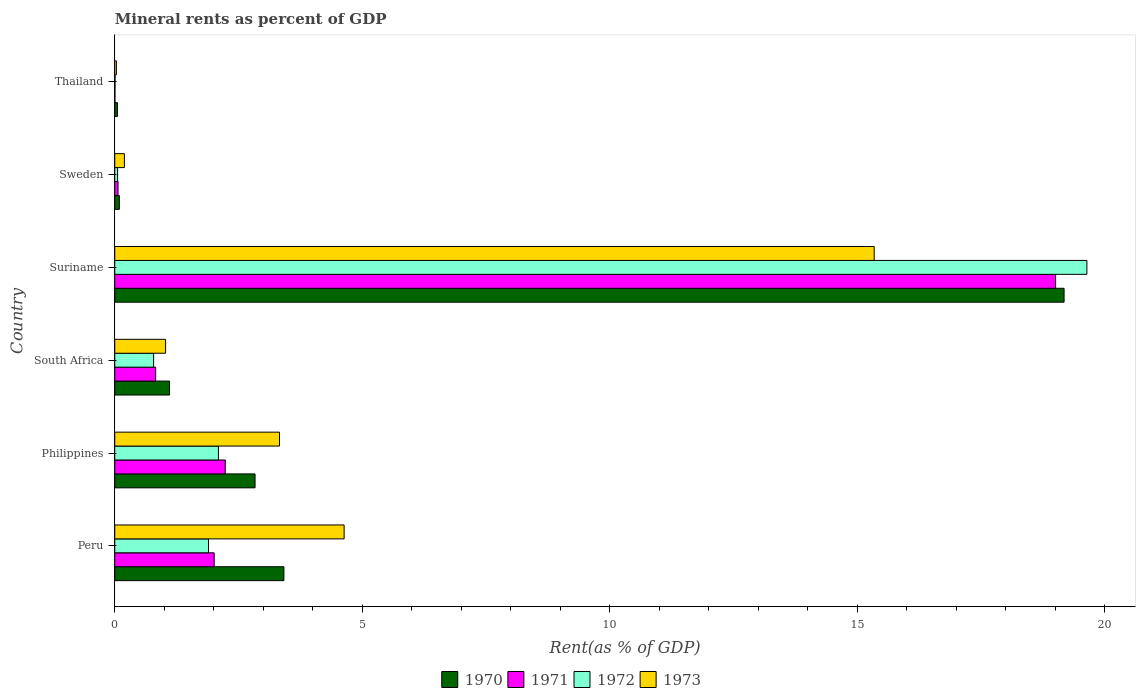How many groups of bars are there?
Your response must be concise. 6. Are the number of bars per tick equal to the number of legend labels?
Your answer should be compact. Yes. Are the number of bars on each tick of the Y-axis equal?
Your answer should be compact. Yes. How many bars are there on the 4th tick from the top?
Provide a short and direct response. 4. How many bars are there on the 1st tick from the bottom?
Provide a succinct answer. 4. What is the label of the 1st group of bars from the top?
Provide a succinct answer. Thailand. In how many cases, is the number of bars for a given country not equal to the number of legend labels?
Keep it short and to the point. 0. What is the mineral rent in 1973 in Thailand?
Keep it short and to the point. 0.03. Across all countries, what is the maximum mineral rent in 1972?
Offer a terse response. 19.63. Across all countries, what is the minimum mineral rent in 1971?
Your answer should be compact. 0. In which country was the mineral rent in 1972 maximum?
Your answer should be compact. Suriname. In which country was the mineral rent in 1971 minimum?
Offer a very short reply. Thailand. What is the total mineral rent in 1973 in the graph?
Offer a terse response. 24.55. What is the difference between the mineral rent in 1971 in Peru and that in Thailand?
Provide a succinct answer. 2. What is the difference between the mineral rent in 1972 in Suriname and the mineral rent in 1973 in Thailand?
Your answer should be compact. 19.6. What is the average mineral rent in 1971 per country?
Give a very brief answer. 4.02. What is the difference between the mineral rent in 1973 and mineral rent in 1972 in Philippines?
Give a very brief answer. 1.23. In how many countries, is the mineral rent in 1972 greater than 5 %?
Your response must be concise. 1. What is the ratio of the mineral rent in 1973 in Philippines to that in Thailand?
Provide a short and direct response. 100.47. Is the mineral rent in 1972 in Philippines less than that in Suriname?
Offer a very short reply. Yes. Is the difference between the mineral rent in 1973 in Philippines and Suriname greater than the difference between the mineral rent in 1972 in Philippines and Suriname?
Your response must be concise. Yes. What is the difference between the highest and the second highest mineral rent in 1972?
Provide a succinct answer. 17.54. What is the difference between the highest and the lowest mineral rent in 1970?
Your answer should be very brief. 19.12. Is it the case that in every country, the sum of the mineral rent in 1971 and mineral rent in 1972 is greater than the sum of mineral rent in 1973 and mineral rent in 1970?
Give a very brief answer. No. What does the 1st bar from the top in Sweden represents?
Provide a succinct answer. 1973. What does the 4th bar from the bottom in Suriname represents?
Offer a very short reply. 1973. How many bars are there?
Keep it short and to the point. 24. How many countries are there in the graph?
Ensure brevity in your answer.  6. What is the difference between two consecutive major ticks on the X-axis?
Offer a terse response. 5. Does the graph contain any zero values?
Give a very brief answer. No. Does the graph contain grids?
Your answer should be very brief. No. How many legend labels are there?
Your response must be concise. 4. How are the legend labels stacked?
Give a very brief answer. Horizontal. What is the title of the graph?
Give a very brief answer. Mineral rents as percent of GDP. What is the label or title of the X-axis?
Give a very brief answer. Rent(as % of GDP). What is the Rent(as % of GDP) of 1970 in Peru?
Provide a short and direct response. 3.42. What is the Rent(as % of GDP) in 1971 in Peru?
Offer a terse response. 2.01. What is the Rent(as % of GDP) of 1972 in Peru?
Make the answer very short. 1.89. What is the Rent(as % of GDP) in 1973 in Peru?
Give a very brief answer. 4.63. What is the Rent(as % of GDP) of 1970 in Philippines?
Offer a terse response. 2.83. What is the Rent(as % of GDP) of 1971 in Philippines?
Give a very brief answer. 2.23. What is the Rent(as % of GDP) in 1972 in Philippines?
Provide a succinct answer. 2.09. What is the Rent(as % of GDP) in 1973 in Philippines?
Keep it short and to the point. 3.33. What is the Rent(as % of GDP) of 1970 in South Africa?
Make the answer very short. 1.11. What is the Rent(as % of GDP) in 1971 in South Africa?
Offer a terse response. 0.83. What is the Rent(as % of GDP) in 1972 in South Africa?
Ensure brevity in your answer.  0.79. What is the Rent(as % of GDP) in 1973 in South Africa?
Provide a short and direct response. 1.03. What is the Rent(as % of GDP) of 1970 in Suriname?
Give a very brief answer. 19.17. What is the Rent(as % of GDP) of 1971 in Suriname?
Ensure brevity in your answer.  19. What is the Rent(as % of GDP) in 1972 in Suriname?
Give a very brief answer. 19.63. What is the Rent(as % of GDP) in 1973 in Suriname?
Offer a terse response. 15.34. What is the Rent(as % of GDP) in 1970 in Sweden?
Keep it short and to the point. 0.09. What is the Rent(as % of GDP) in 1971 in Sweden?
Keep it short and to the point. 0.07. What is the Rent(as % of GDP) of 1972 in Sweden?
Your answer should be compact. 0.06. What is the Rent(as % of GDP) of 1973 in Sweden?
Provide a short and direct response. 0.2. What is the Rent(as % of GDP) in 1970 in Thailand?
Keep it short and to the point. 0.05. What is the Rent(as % of GDP) in 1971 in Thailand?
Provide a succinct answer. 0. What is the Rent(as % of GDP) of 1972 in Thailand?
Make the answer very short. 0.01. What is the Rent(as % of GDP) of 1973 in Thailand?
Offer a terse response. 0.03. Across all countries, what is the maximum Rent(as % of GDP) of 1970?
Provide a short and direct response. 19.17. Across all countries, what is the maximum Rent(as % of GDP) in 1971?
Offer a very short reply. 19. Across all countries, what is the maximum Rent(as % of GDP) in 1972?
Your answer should be compact. 19.63. Across all countries, what is the maximum Rent(as % of GDP) in 1973?
Ensure brevity in your answer.  15.34. Across all countries, what is the minimum Rent(as % of GDP) of 1970?
Ensure brevity in your answer.  0.05. Across all countries, what is the minimum Rent(as % of GDP) of 1971?
Ensure brevity in your answer.  0. Across all countries, what is the minimum Rent(as % of GDP) of 1972?
Offer a very short reply. 0.01. Across all countries, what is the minimum Rent(as % of GDP) in 1973?
Offer a very short reply. 0.03. What is the total Rent(as % of GDP) of 1970 in the graph?
Make the answer very short. 26.68. What is the total Rent(as % of GDP) of 1971 in the graph?
Provide a short and direct response. 24.14. What is the total Rent(as % of GDP) of 1972 in the graph?
Your answer should be very brief. 24.47. What is the total Rent(as % of GDP) of 1973 in the graph?
Your answer should be very brief. 24.55. What is the difference between the Rent(as % of GDP) in 1970 in Peru and that in Philippines?
Offer a very short reply. 0.58. What is the difference between the Rent(as % of GDP) of 1971 in Peru and that in Philippines?
Offer a terse response. -0.22. What is the difference between the Rent(as % of GDP) in 1972 in Peru and that in Philippines?
Offer a terse response. -0.2. What is the difference between the Rent(as % of GDP) in 1973 in Peru and that in Philippines?
Provide a succinct answer. 1.31. What is the difference between the Rent(as % of GDP) in 1970 in Peru and that in South Africa?
Provide a succinct answer. 2.31. What is the difference between the Rent(as % of GDP) of 1971 in Peru and that in South Africa?
Give a very brief answer. 1.18. What is the difference between the Rent(as % of GDP) of 1972 in Peru and that in South Africa?
Provide a succinct answer. 1.11. What is the difference between the Rent(as % of GDP) of 1973 in Peru and that in South Africa?
Offer a very short reply. 3.61. What is the difference between the Rent(as % of GDP) in 1970 in Peru and that in Suriname?
Make the answer very short. -15.76. What is the difference between the Rent(as % of GDP) of 1971 in Peru and that in Suriname?
Provide a short and direct response. -16.99. What is the difference between the Rent(as % of GDP) of 1972 in Peru and that in Suriname?
Ensure brevity in your answer.  -17.74. What is the difference between the Rent(as % of GDP) in 1973 in Peru and that in Suriname?
Your answer should be very brief. -10.71. What is the difference between the Rent(as % of GDP) of 1970 in Peru and that in Sweden?
Provide a short and direct response. 3.32. What is the difference between the Rent(as % of GDP) of 1971 in Peru and that in Sweden?
Keep it short and to the point. 1.94. What is the difference between the Rent(as % of GDP) of 1972 in Peru and that in Sweden?
Ensure brevity in your answer.  1.84. What is the difference between the Rent(as % of GDP) in 1973 in Peru and that in Sweden?
Provide a short and direct response. 4.44. What is the difference between the Rent(as % of GDP) of 1970 in Peru and that in Thailand?
Your answer should be compact. 3.36. What is the difference between the Rent(as % of GDP) in 1971 in Peru and that in Thailand?
Provide a short and direct response. 2. What is the difference between the Rent(as % of GDP) of 1972 in Peru and that in Thailand?
Provide a short and direct response. 1.89. What is the difference between the Rent(as % of GDP) in 1973 in Peru and that in Thailand?
Provide a short and direct response. 4.6. What is the difference between the Rent(as % of GDP) of 1970 in Philippines and that in South Africa?
Keep it short and to the point. 1.73. What is the difference between the Rent(as % of GDP) in 1971 in Philippines and that in South Africa?
Your answer should be compact. 1.41. What is the difference between the Rent(as % of GDP) in 1972 in Philippines and that in South Africa?
Provide a succinct answer. 1.31. What is the difference between the Rent(as % of GDP) of 1973 in Philippines and that in South Africa?
Ensure brevity in your answer.  2.3. What is the difference between the Rent(as % of GDP) in 1970 in Philippines and that in Suriname?
Offer a terse response. -16.34. What is the difference between the Rent(as % of GDP) in 1971 in Philippines and that in Suriname?
Your response must be concise. -16.77. What is the difference between the Rent(as % of GDP) in 1972 in Philippines and that in Suriname?
Make the answer very short. -17.54. What is the difference between the Rent(as % of GDP) of 1973 in Philippines and that in Suriname?
Your answer should be compact. -12.01. What is the difference between the Rent(as % of GDP) of 1970 in Philippines and that in Sweden?
Keep it short and to the point. 2.74. What is the difference between the Rent(as % of GDP) in 1971 in Philippines and that in Sweden?
Provide a succinct answer. 2.17. What is the difference between the Rent(as % of GDP) in 1972 in Philippines and that in Sweden?
Your response must be concise. 2.04. What is the difference between the Rent(as % of GDP) in 1973 in Philippines and that in Sweden?
Provide a short and direct response. 3.13. What is the difference between the Rent(as % of GDP) of 1970 in Philippines and that in Thailand?
Provide a succinct answer. 2.78. What is the difference between the Rent(as % of GDP) in 1971 in Philippines and that in Thailand?
Your response must be concise. 2.23. What is the difference between the Rent(as % of GDP) of 1972 in Philippines and that in Thailand?
Offer a very short reply. 2.09. What is the difference between the Rent(as % of GDP) of 1973 in Philippines and that in Thailand?
Provide a succinct answer. 3.29. What is the difference between the Rent(as % of GDP) in 1970 in South Africa and that in Suriname?
Ensure brevity in your answer.  -18.07. What is the difference between the Rent(as % of GDP) of 1971 in South Africa and that in Suriname?
Your answer should be compact. -18.18. What is the difference between the Rent(as % of GDP) in 1972 in South Africa and that in Suriname?
Offer a terse response. -18.85. What is the difference between the Rent(as % of GDP) of 1973 in South Africa and that in Suriname?
Provide a succinct answer. -14.31. What is the difference between the Rent(as % of GDP) in 1970 in South Africa and that in Sweden?
Offer a very short reply. 1.01. What is the difference between the Rent(as % of GDP) in 1971 in South Africa and that in Sweden?
Offer a very short reply. 0.76. What is the difference between the Rent(as % of GDP) in 1972 in South Africa and that in Sweden?
Your answer should be very brief. 0.73. What is the difference between the Rent(as % of GDP) in 1973 in South Africa and that in Sweden?
Provide a short and direct response. 0.83. What is the difference between the Rent(as % of GDP) of 1970 in South Africa and that in Thailand?
Provide a short and direct response. 1.05. What is the difference between the Rent(as % of GDP) of 1971 in South Africa and that in Thailand?
Keep it short and to the point. 0.82. What is the difference between the Rent(as % of GDP) in 1972 in South Africa and that in Thailand?
Offer a terse response. 0.78. What is the difference between the Rent(as % of GDP) of 1970 in Suriname and that in Sweden?
Your answer should be compact. 19.08. What is the difference between the Rent(as % of GDP) of 1971 in Suriname and that in Sweden?
Your answer should be compact. 18.94. What is the difference between the Rent(as % of GDP) in 1972 in Suriname and that in Sweden?
Keep it short and to the point. 19.58. What is the difference between the Rent(as % of GDP) of 1973 in Suriname and that in Sweden?
Provide a short and direct response. 15.14. What is the difference between the Rent(as % of GDP) in 1970 in Suriname and that in Thailand?
Provide a succinct answer. 19.12. What is the difference between the Rent(as % of GDP) in 1971 in Suriname and that in Thailand?
Offer a very short reply. 19. What is the difference between the Rent(as % of GDP) in 1972 in Suriname and that in Thailand?
Your answer should be compact. 19.63. What is the difference between the Rent(as % of GDP) of 1973 in Suriname and that in Thailand?
Give a very brief answer. 15.31. What is the difference between the Rent(as % of GDP) in 1970 in Sweden and that in Thailand?
Offer a very short reply. 0.04. What is the difference between the Rent(as % of GDP) of 1971 in Sweden and that in Thailand?
Ensure brevity in your answer.  0.06. What is the difference between the Rent(as % of GDP) of 1972 in Sweden and that in Thailand?
Your response must be concise. 0.05. What is the difference between the Rent(as % of GDP) in 1973 in Sweden and that in Thailand?
Give a very brief answer. 0.16. What is the difference between the Rent(as % of GDP) of 1970 in Peru and the Rent(as % of GDP) of 1971 in Philippines?
Your answer should be very brief. 1.18. What is the difference between the Rent(as % of GDP) in 1970 in Peru and the Rent(as % of GDP) in 1972 in Philippines?
Make the answer very short. 1.32. What is the difference between the Rent(as % of GDP) in 1970 in Peru and the Rent(as % of GDP) in 1973 in Philippines?
Your answer should be compact. 0.09. What is the difference between the Rent(as % of GDP) of 1971 in Peru and the Rent(as % of GDP) of 1972 in Philippines?
Provide a succinct answer. -0.09. What is the difference between the Rent(as % of GDP) in 1971 in Peru and the Rent(as % of GDP) in 1973 in Philippines?
Give a very brief answer. -1.32. What is the difference between the Rent(as % of GDP) of 1972 in Peru and the Rent(as % of GDP) of 1973 in Philippines?
Your answer should be compact. -1.43. What is the difference between the Rent(as % of GDP) in 1970 in Peru and the Rent(as % of GDP) in 1971 in South Africa?
Your response must be concise. 2.59. What is the difference between the Rent(as % of GDP) of 1970 in Peru and the Rent(as % of GDP) of 1972 in South Africa?
Provide a short and direct response. 2.63. What is the difference between the Rent(as % of GDP) of 1970 in Peru and the Rent(as % of GDP) of 1973 in South Africa?
Keep it short and to the point. 2.39. What is the difference between the Rent(as % of GDP) of 1971 in Peru and the Rent(as % of GDP) of 1972 in South Africa?
Make the answer very short. 1.22. What is the difference between the Rent(as % of GDP) in 1971 in Peru and the Rent(as % of GDP) in 1973 in South Africa?
Keep it short and to the point. 0.98. What is the difference between the Rent(as % of GDP) of 1972 in Peru and the Rent(as % of GDP) of 1973 in South Africa?
Offer a very short reply. 0.87. What is the difference between the Rent(as % of GDP) in 1970 in Peru and the Rent(as % of GDP) in 1971 in Suriname?
Your answer should be very brief. -15.59. What is the difference between the Rent(as % of GDP) in 1970 in Peru and the Rent(as % of GDP) in 1972 in Suriname?
Your answer should be very brief. -16.22. What is the difference between the Rent(as % of GDP) of 1970 in Peru and the Rent(as % of GDP) of 1973 in Suriname?
Provide a short and direct response. -11.92. What is the difference between the Rent(as % of GDP) in 1971 in Peru and the Rent(as % of GDP) in 1972 in Suriname?
Give a very brief answer. -17.63. What is the difference between the Rent(as % of GDP) in 1971 in Peru and the Rent(as % of GDP) in 1973 in Suriname?
Your answer should be compact. -13.33. What is the difference between the Rent(as % of GDP) in 1972 in Peru and the Rent(as % of GDP) in 1973 in Suriname?
Your answer should be very brief. -13.44. What is the difference between the Rent(as % of GDP) of 1970 in Peru and the Rent(as % of GDP) of 1971 in Sweden?
Give a very brief answer. 3.35. What is the difference between the Rent(as % of GDP) of 1970 in Peru and the Rent(as % of GDP) of 1972 in Sweden?
Offer a very short reply. 3.36. What is the difference between the Rent(as % of GDP) in 1970 in Peru and the Rent(as % of GDP) in 1973 in Sweden?
Ensure brevity in your answer.  3.22. What is the difference between the Rent(as % of GDP) of 1971 in Peru and the Rent(as % of GDP) of 1972 in Sweden?
Offer a terse response. 1.95. What is the difference between the Rent(as % of GDP) in 1971 in Peru and the Rent(as % of GDP) in 1973 in Sweden?
Offer a very short reply. 1.81. What is the difference between the Rent(as % of GDP) in 1972 in Peru and the Rent(as % of GDP) in 1973 in Sweden?
Give a very brief answer. 1.7. What is the difference between the Rent(as % of GDP) of 1970 in Peru and the Rent(as % of GDP) of 1971 in Thailand?
Provide a succinct answer. 3.41. What is the difference between the Rent(as % of GDP) in 1970 in Peru and the Rent(as % of GDP) in 1972 in Thailand?
Ensure brevity in your answer.  3.41. What is the difference between the Rent(as % of GDP) in 1970 in Peru and the Rent(as % of GDP) in 1973 in Thailand?
Make the answer very short. 3.38. What is the difference between the Rent(as % of GDP) in 1971 in Peru and the Rent(as % of GDP) in 1972 in Thailand?
Your answer should be very brief. 2. What is the difference between the Rent(as % of GDP) in 1971 in Peru and the Rent(as % of GDP) in 1973 in Thailand?
Offer a terse response. 1.97. What is the difference between the Rent(as % of GDP) in 1972 in Peru and the Rent(as % of GDP) in 1973 in Thailand?
Offer a very short reply. 1.86. What is the difference between the Rent(as % of GDP) of 1970 in Philippines and the Rent(as % of GDP) of 1971 in South Africa?
Your answer should be very brief. 2.01. What is the difference between the Rent(as % of GDP) in 1970 in Philippines and the Rent(as % of GDP) in 1972 in South Africa?
Ensure brevity in your answer.  2.05. What is the difference between the Rent(as % of GDP) in 1970 in Philippines and the Rent(as % of GDP) in 1973 in South Africa?
Provide a short and direct response. 1.81. What is the difference between the Rent(as % of GDP) in 1971 in Philippines and the Rent(as % of GDP) in 1972 in South Africa?
Ensure brevity in your answer.  1.45. What is the difference between the Rent(as % of GDP) of 1971 in Philippines and the Rent(as % of GDP) of 1973 in South Africa?
Your answer should be compact. 1.2. What is the difference between the Rent(as % of GDP) in 1972 in Philippines and the Rent(as % of GDP) in 1973 in South Africa?
Offer a very short reply. 1.07. What is the difference between the Rent(as % of GDP) of 1970 in Philippines and the Rent(as % of GDP) of 1971 in Suriname?
Provide a succinct answer. -16.17. What is the difference between the Rent(as % of GDP) of 1970 in Philippines and the Rent(as % of GDP) of 1972 in Suriname?
Keep it short and to the point. -16.8. What is the difference between the Rent(as % of GDP) of 1970 in Philippines and the Rent(as % of GDP) of 1973 in Suriname?
Your answer should be very brief. -12.51. What is the difference between the Rent(as % of GDP) in 1971 in Philippines and the Rent(as % of GDP) in 1972 in Suriname?
Provide a short and direct response. -17.4. What is the difference between the Rent(as % of GDP) of 1971 in Philippines and the Rent(as % of GDP) of 1973 in Suriname?
Your response must be concise. -13.11. What is the difference between the Rent(as % of GDP) of 1972 in Philippines and the Rent(as % of GDP) of 1973 in Suriname?
Provide a short and direct response. -13.24. What is the difference between the Rent(as % of GDP) in 1970 in Philippines and the Rent(as % of GDP) in 1971 in Sweden?
Provide a succinct answer. 2.77. What is the difference between the Rent(as % of GDP) of 1970 in Philippines and the Rent(as % of GDP) of 1972 in Sweden?
Make the answer very short. 2.78. What is the difference between the Rent(as % of GDP) of 1970 in Philippines and the Rent(as % of GDP) of 1973 in Sweden?
Provide a succinct answer. 2.64. What is the difference between the Rent(as % of GDP) in 1971 in Philippines and the Rent(as % of GDP) in 1972 in Sweden?
Ensure brevity in your answer.  2.17. What is the difference between the Rent(as % of GDP) in 1971 in Philippines and the Rent(as % of GDP) in 1973 in Sweden?
Offer a terse response. 2.04. What is the difference between the Rent(as % of GDP) in 1972 in Philippines and the Rent(as % of GDP) in 1973 in Sweden?
Keep it short and to the point. 1.9. What is the difference between the Rent(as % of GDP) in 1970 in Philippines and the Rent(as % of GDP) in 1971 in Thailand?
Offer a very short reply. 2.83. What is the difference between the Rent(as % of GDP) in 1970 in Philippines and the Rent(as % of GDP) in 1972 in Thailand?
Offer a terse response. 2.83. What is the difference between the Rent(as % of GDP) in 1970 in Philippines and the Rent(as % of GDP) in 1973 in Thailand?
Your answer should be very brief. 2.8. What is the difference between the Rent(as % of GDP) of 1971 in Philippines and the Rent(as % of GDP) of 1972 in Thailand?
Give a very brief answer. 2.23. What is the difference between the Rent(as % of GDP) of 1971 in Philippines and the Rent(as % of GDP) of 1973 in Thailand?
Give a very brief answer. 2.2. What is the difference between the Rent(as % of GDP) in 1972 in Philippines and the Rent(as % of GDP) in 1973 in Thailand?
Your answer should be very brief. 2.06. What is the difference between the Rent(as % of GDP) in 1970 in South Africa and the Rent(as % of GDP) in 1971 in Suriname?
Give a very brief answer. -17.9. What is the difference between the Rent(as % of GDP) in 1970 in South Africa and the Rent(as % of GDP) in 1972 in Suriname?
Make the answer very short. -18.53. What is the difference between the Rent(as % of GDP) in 1970 in South Africa and the Rent(as % of GDP) in 1973 in Suriname?
Ensure brevity in your answer.  -14.23. What is the difference between the Rent(as % of GDP) of 1971 in South Africa and the Rent(as % of GDP) of 1972 in Suriname?
Your answer should be compact. -18.81. What is the difference between the Rent(as % of GDP) in 1971 in South Africa and the Rent(as % of GDP) in 1973 in Suriname?
Your answer should be compact. -14.51. What is the difference between the Rent(as % of GDP) in 1972 in South Africa and the Rent(as % of GDP) in 1973 in Suriname?
Give a very brief answer. -14.55. What is the difference between the Rent(as % of GDP) in 1970 in South Africa and the Rent(as % of GDP) in 1971 in Sweden?
Provide a succinct answer. 1.04. What is the difference between the Rent(as % of GDP) of 1970 in South Africa and the Rent(as % of GDP) of 1972 in Sweden?
Your answer should be very brief. 1.05. What is the difference between the Rent(as % of GDP) of 1970 in South Africa and the Rent(as % of GDP) of 1973 in Sweden?
Provide a short and direct response. 0.91. What is the difference between the Rent(as % of GDP) in 1971 in South Africa and the Rent(as % of GDP) in 1972 in Sweden?
Your response must be concise. 0.77. What is the difference between the Rent(as % of GDP) in 1971 in South Africa and the Rent(as % of GDP) in 1973 in Sweden?
Your response must be concise. 0.63. What is the difference between the Rent(as % of GDP) in 1972 in South Africa and the Rent(as % of GDP) in 1973 in Sweden?
Offer a terse response. 0.59. What is the difference between the Rent(as % of GDP) of 1970 in South Africa and the Rent(as % of GDP) of 1971 in Thailand?
Your answer should be very brief. 1.1. What is the difference between the Rent(as % of GDP) in 1970 in South Africa and the Rent(as % of GDP) in 1972 in Thailand?
Make the answer very short. 1.1. What is the difference between the Rent(as % of GDP) in 1970 in South Africa and the Rent(as % of GDP) in 1973 in Thailand?
Offer a terse response. 1.07. What is the difference between the Rent(as % of GDP) in 1971 in South Africa and the Rent(as % of GDP) in 1972 in Thailand?
Offer a very short reply. 0.82. What is the difference between the Rent(as % of GDP) in 1971 in South Africa and the Rent(as % of GDP) in 1973 in Thailand?
Ensure brevity in your answer.  0.79. What is the difference between the Rent(as % of GDP) in 1972 in South Africa and the Rent(as % of GDP) in 1973 in Thailand?
Your response must be concise. 0.75. What is the difference between the Rent(as % of GDP) in 1970 in Suriname and the Rent(as % of GDP) in 1971 in Sweden?
Your answer should be very brief. 19.11. What is the difference between the Rent(as % of GDP) in 1970 in Suriname and the Rent(as % of GDP) in 1972 in Sweden?
Provide a succinct answer. 19.12. What is the difference between the Rent(as % of GDP) in 1970 in Suriname and the Rent(as % of GDP) in 1973 in Sweden?
Make the answer very short. 18.98. What is the difference between the Rent(as % of GDP) of 1971 in Suriname and the Rent(as % of GDP) of 1972 in Sweden?
Ensure brevity in your answer.  18.95. What is the difference between the Rent(as % of GDP) in 1971 in Suriname and the Rent(as % of GDP) in 1973 in Sweden?
Make the answer very short. 18.81. What is the difference between the Rent(as % of GDP) of 1972 in Suriname and the Rent(as % of GDP) of 1973 in Sweden?
Your answer should be very brief. 19.44. What is the difference between the Rent(as % of GDP) in 1970 in Suriname and the Rent(as % of GDP) in 1971 in Thailand?
Offer a terse response. 19.17. What is the difference between the Rent(as % of GDP) in 1970 in Suriname and the Rent(as % of GDP) in 1972 in Thailand?
Your response must be concise. 19.17. What is the difference between the Rent(as % of GDP) in 1970 in Suriname and the Rent(as % of GDP) in 1973 in Thailand?
Make the answer very short. 19.14. What is the difference between the Rent(as % of GDP) of 1971 in Suriname and the Rent(as % of GDP) of 1972 in Thailand?
Make the answer very short. 19. What is the difference between the Rent(as % of GDP) of 1971 in Suriname and the Rent(as % of GDP) of 1973 in Thailand?
Offer a very short reply. 18.97. What is the difference between the Rent(as % of GDP) in 1972 in Suriname and the Rent(as % of GDP) in 1973 in Thailand?
Your response must be concise. 19.6. What is the difference between the Rent(as % of GDP) in 1970 in Sweden and the Rent(as % of GDP) in 1971 in Thailand?
Your response must be concise. 0.09. What is the difference between the Rent(as % of GDP) of 1970 in Sweden and the Rent(as % of GDP) of 1972 in Thailand?
Offer a terse response. 0.09. What is the difference between the Rent(as % of GDP) in 1970 in Sweden and the Rent(as % of GDP) in 1973 in Thailand?
Offer a terse response. 0.06. What is the difference between the Rent(as % of GDP) of 1971 in Sweden and the Rent(as % of GDP) of 1972 in Thailand?
Offer a very short reply. 0.06. What is the difference between the Rent(as % of GDP) in 1971 in Sweden and the Rent(as % of GDP) in 1973 in Thailand?
Your response must be concise. 0.03. What is the difference between the Rent(as % of GDP) of 1972 in Sweden and the Rent(as % of GDP) of 1973 in Thailand?
Your response must be concise. 0.02. What is the average Rent(as % of GDP) of 1970 per country?
Ensure brevity in your answer.  4.45. What is the average Rent(as % of GDP) of 1971 per country?
Provide a succinct answer. 4.02. What is the average Rent(as % of GDP) of 1972 per country?
Offer a very short reply. 4.08. What is the average Rent(as % of GDP) in 1973 per country?
Provide a short and direct response. 4.09. What is the difference between the Rent(as % of GDP) in 1970 and Rent(as % of GDP) in 1971 in Peru?
Ensure brevity in your answer.  1.41. What is the difference between the Rent(as % of GDP) of 1970 and Rent(as % of GDP) of 1972 in Peru?
Ensure brevity in your answer.  1.52. What is the difference between the Rent(as % of GDP) in 1970 and Rent(as % of GDP) in 1973 in Peru?
Your answer should be very brief. -1.22. What is the difference between the Rent(as % of GDP) in 1971 and Rent(as % of GDP) in 1972 in Peru?
Your answer should be very brief. 0.11. What is the difference between the Rent(as % of GDP) in 1971 and Rent(as % of GDP) in 1973 in Peru?
Offer a very short reply. -2.62. What is the difference between the Rent(as % of GDP) of 1972 and Rent(as % of GDP) of 1973 in Peru?
Provide a succinct answer. -2.74. What is the difference between the Rent(as % of GDP) in 1970 and Rent(as % of GDP) in 1971 in Philippines?
Offer a very short reply. 0.6. What is the difference between the Rent(as % of GDP) of 1970 and Rent(as % of GDP) of 1972 in Philippines?
Make the answer very short. 0.74. What is the difference between the Rent(as % of GDP) of 1970 and Rent(as % of GDP) of 1973 in Philippines?
Offer a terse response. -0.49. What is the difference between the Rent(as % of GDP) in 1971 and Rent(as % of GDP) in 1972 in Philippines?
Your answer should be very brief. 0.14. What is the difference between the Rent(as % of GDP) in 1971 and Rent(as % of GDP) in 1973 in Philippines?
Keep it short and to the point. -1.1. What is the difference between the Rent(as % of GDP) of 1972 and Rent(as % of GDP) of 1973 in Philippines?
Make the answer very short. -1.23. What is the difference between the Rent(as % of GDP) of 1970 and Rent(as % of GDP) of 1971 in South Africa?
Offer a very short reply. 0.28. What is the difference between the Rent(as % of GDP) in 1970 and Rent(as % of GDP) in 1972 in South Africa?
Ensure brevity in your answer.  0.32. What is the difference between the Rent(as % of GDP) in 1970 and Rent(as % of GDP) in 1973 in South Africa?
Provide a short and direct response. 0.08. What is the difference between the Rent(as % of GDP) in 1971 and Rent(as % of GDP) in 1972 in South Africa?
Keep it short and to the point. 0.04. What is the difference between the Rent(as % of GDP) in 1971 and Rent(as % of GDP) in 1973 in South Africa?
Provide a short and direct response. -0.2. What is the difference between the Rent(as % of GDP) of 1972 and Rent(as % of GDP) of 1973 in South Africa?
Offer a terse response. -0.24. What is the difference between the Rent(as % of GDP) in 1970 and Rent(as % of GDP) in 1971 in Suriname?
Provide a short and direct response. 0.17. What is the difference between the Rent(as % of GDP) in 1970 and Rent(as % of GDP) in 1972 in Suriname?
Make the answer very short. -0.46. What is the difference between the Rent(as % of GDP) of 1970 and Rent(as % of GDP) of 1973 in Suriname?
Provide a succinct answer. 3.84. What is the difference between the Rent(as % of GDP) in 1971 and Rent(as % of GDP) in 1972 in Suriname?
Make the answer very short. -0.63. What is the difference between the Rent(as % of GDP) in 1971 and Rent(as % of GDP) in 1973 in Suriname?
Your answer should be very brief. 3.66. What is the difference between the Rent(as % of GDP) of 1972 and Rent(as % of GDP) of 1973 in Suriname?
Your response must be concise. 4.3. What is the difference between the Rent(as % of GDP) in 1970 and Rent(as % of GDP) in 1971 in Sweden?
Provide a short and direct response. 0.03. What is the difference between the Rent(as % of GDP) in 1970 and Rent(as % of GDP) in 1972 in Sweden?
Offer a very short reply. 0.04. What is the difference between the Rent(as % of GDP) in 1970 and Rent(as % of GDP) in 1973 in Sweden?
Keep it short and to the point. -0.1. What is the difference between the Rent(as % of GDP) in 1971 and Rent(as % of GDP) in 1972 in Sweden?
Provide a short and direct response. 0.01. What is the difference between the Rent(as % of GDP) of 1971 and Rent(as % of GDP) of 1973 in Sweden?
Your answer should be compact. -0.13. What is the difference between the Rent(as % of GDP) in 1972 and Rent(as % of GDP) in 1973 in Sweden?
Provide a succinct answer. -0.14. What is the difference between the Rent(as % of GDP) of 1970 and Rent(as % of GDP) of 1971 in Thailand?
Offer a very short reply. 0.05. What is the difference between the Rent(as % of GDP) in 1970 and Rent(as % of GDP) in 1972 in Thailand?
Provide a short and direct response. 0.05. What is the difference between the Rent(as % of GDP) in 1970 and Rent(as % of GDP) in 1973 in Thailand?
Your response must be concise. 0.02. What is the difference between the Rent(as % of GDP) of 1971 and Rent(as % of GDP) of 1972 in Thailand?
Offer a very short reply. -0. What is the difference between the Rent(as % of GDP) of 1971 and Rent(as % of GDP) of 1973 in Thailand?
Make the answer very short. -0.03. What is the difference between the Rent(as % of GDP) of 1972 and Rent(as % of GDP) of 1973 in Thailand?
Keep it short and to the point. -0.03. What is the ratio of the Rent(as % of GDP) in 1970 in Peru to that in Philippines?
Your answer should be very brief. 1.21. What is the ratio of the Rent(as % of GDP) in 1971 in Peru to that in Philippines?
Your answer should be compact. 0.9. What is the ratio of the Rent(as % of GDP) of 1972 in Peru to that in Philippines?
Provide a short and direct response. 0.9. What is the ratio of the Rent(as % of GDP) in 1973 in Peru to that in Philippines?
Your answer should be compact. 1.39. What is the ratio of the Rent(as % of GDP) in 1970 in Peru to that in South Africa?
Your answer should be compact. 3.09. What is the ratio of the Rent(as % of GDP) in 1971 in Peru to that in South Africa?
Offer a terse response. 2.43. What is the ratio of the Rent(as % of GDP) in 1972 in Peru to that in South Africa?
Give a very brief answer. 2.41. What is the ratio of the Rent(as % of GDP) of 1973 in Peru to that in South Africa?
Offer a terse response. 4.51. What is the ratio of the Rent(as % of GDP) in 1970 in Peru to that in Suriname?
Provide a short and direct response. 0.18. What is the ratio of the Rent(as % of GDP) in 1971 in Peru to that in Suriname?
Ensure brevity in your answer.  0.11. What is the ratio of the Rent(as % of GDP) in 1972 in Peru to that in Suriname?
Your answer should be compact. 0.1. What is the ratio of the Rent(as % of GDP) of 1973 in Peru to that in Suriname?
Make the answer very short. 0.3. What is the ratio of the Rent(as % of GDP) in 1970 in Peru to that in Sweden?
Your answer should be very brief. 36.88. What is the ratio of the Rent(as % of GDP) in 1971 in Peru to that in Sweden?
Provide a short and direct response. 30.33. What is the ratio of the Rent(as % of GDP) in 1972 in Peru to that in Sweden?
Offer a terse response. 32.98. What is the ratio of the Rent(as % of GDP) in 1973 in Peru to that in Sweden?
Make the answer very short. 23.72. What is the ratio of the Rent(as % of GDP) of 1970 in Peru to that in Thailand?
Keep it short and to the point. 63.26. What is the ratio of the Rent(as % of GDP) in 1971 in Peru to that in Thailand?
Provide a short and direct response. 627.74. What is the ratio of the Rent(as % of GDP) of 1972 in Peru to that in Thailand?
Your answer should be very brief. 373.59. What is the ratio of the Rent(as % of GDP) in 1973 in Peru to that in Thailand?
Your answer should be compact. 139.88. What is the ratio of the Rent(as % of GDP) of 1970 in Philippines to that in South Africa?
Keep it short and to the point. 2.56. What is the ratio of the Rent(as % of GDP) in 1971 in Philippines to that in South Africa?
Keep it short and to the point. 2.7. What is the ratio of the Rent(as % of GDP) in 1972 in Philippines to that in South Africa?
Ensure brevity in your answer.  2.67. What is the ratio of the Rent(as % of GDP) of 1973 in Philippines to that in South Africa?
Your response must be concise. 3.24. What is the ratio of the Rent(as % of GDP) of 1970 in Philippines to that in Suriname?
Ensure brevity in your answer.  0.15. What is the ratio of the Rent(as % of GDP) of 1971 in Philippines to that in Suriname?
Your response must be concise. 0.12. What is the ratio of the Rent(as % of GDP) of 1972 in Philippines to that in Suriname?
Offer a very short reply. 0.11. What is the ratio of the Rent(as % of GDP) of 1973 in Philippines to that in Suriname?
Provide a short and direct response. 0.22. What is the ratio of the Rent(as % of GDP) of 1970 in Philippines to that in Sweden?
Keep it short and to the point. 30.59. What is the ratio of the Rent(as % of GDP) of 1971 in Philippines to that in Sweden?
Your answer should be very brief. 33.7. What is the ratio of the Rent(as % of GDP) of 1972 in Philippines to that in Sweden?
Your answer should be compact. 36.47. What is the ratio of the Rent(as % of GDP) in 1973 in Philippines to that in Sweden?
Offer a terse response. 17.03. What is the ratio of the Rent(as % of GDP) of 1970 in Philippines to that in Thailand?
Your answer should be very brief. 52.47. What is the ratio of the Rent(as % of GDP) in 1971 in Philippines to that in Thailand?
Give a very brief answer. 697.65. What is the ratio of the Rent(as % of GDP) of 1972 in Philippines to that in Thailand?
Make the answer very short. 413.11. What is the ratio of the Rent(as % of GDP) in 1973 in Philippines to that in Thailand?
Offer a terse response. 100.47. What is the ratio of the Rent(as % of GDP) in 1970 in South Africa to that in Suriname?
Keep it short and to the point. 0.06. What is the ratio of the Rent(as % of GDP) of 1971 in South Africa to that in Suriname?
Provide a short and direct response. 0.04. What is the ratio of the Rent(as % of GDP) in 1972 in South Africa to that in Suriname?
Your answer should be very brief. 0.04. What is the ratio of the Rent(as % of GDP) in 1973 in South Africa to that in Suriname?
Give a very brief answer. 0.07. What is the ratio of the Rent(as % of GDP) of 1970 in South Africa to that in Sweden?
Give a very brief answer. 11.94. What is the ratio of the Rent(as % of GDP) of 1971 in South Africa to that in Sweden?
Your answer should be very brief. 12.48. What is the ratio of the Rent(as % of GDP) of 1972 in South Africa to that in Sweden?
Your answer should be very brief. 13.67. What is the ratio of the Rent(as % of GDP) of 1973 in South Africa to that in Sweden?
Your answer should be very brief. 5.26. What is the ratio of the Rent(as % of GDP) in 1970 in South Africa to that in Thailand?
Offer a terse response. 20.48. What is the ratio of the Rent(as % of GDP) in 1971 in South Africa to that in Thailand?
Give a very brief answer. 258.3. What is the ratio of the Rent(as % of GDP) of 1972 in South Africa to that in Thailand?
Provide a succinct answer. 154.88. What is the ratio of the Rent(as % of GDP) of 1973 in South Africa to that in Thailand?
Your response must be concise. 31.01. What is the ratio of the Rent(as % of GDP) in 1970 in Suriname to that in Sweden?
Offer a terse response. 207. What is the ratio of the Rent(as % of GDP) of 1971 in Suriname to that in Sweden?
Your answer should be very brief. 287. What is the ratio of the Rent(as % of GDP) in 1972 in Suriname to that in Sweden?
Give a very brief answer. 341.94. What is the ratio of the Rent(as % of GDP) in 1973 in Suriname to that in Sweden?
Offer a very short reply. 78.52. What is the ratio of the Rent(as % of GDP) of 1970 in Suriname to that in Thailand?
Your response must be concise. 355.06. What is the ratio of the Rent(as % of GDP) of 1971 in Suriname to that in Thailand?
Offer a very short reply. 5940.64. What is the ratio of the Rent(as % of GDP) in 1972 in Suriname to that in Thailand?
Offer a very short reply. 3873.35. What is the ratio of the Rent(as % of GDP) of 1973 in Suriname to that in Thailand?
Make the answer very short. 463.15. What is the ratio of the Rent(as % of GDP) of 1970 in Sweden to that in Thailand?
Provide a succinct answer. 1.72. What is the ratio of the Rent(as % of GDP) of 1971 in Sweden to that in Thailand?
Give a very brief answer. 20.7. What is the ratio of the Rent(as % of GDP) of 1972 in Sweden to that in Thailand?
Ensure brevity in your answer.  11.33. What is the ratio of the Rent(as % of GDP) in 1973 in Sweden to that in Thailand?
Offer a very short reply. 5.9. What is the difference between the highest and the second highest Rent(as % of GDP) in 1970?
Provide a short and direct response. 15.76. What is the difference between the highest and the second highest Rent(as % of GDP) of 1971?
Your response must be concise. 16.77. What is the difference between the highest and the second highest Rent(as % of GDP) in 1972?
Offer a very short reply. 17.54. What is the difference between the highest and the second highest Rent(as % of GDP) in 1973?
Your answer should be compact. 10.71. What is the difference between the highest and the lowest Rent(as % of GDP) in 1970?
Provide a short and direct response. 19.12. What is the difference between the highest and the lowest Rent(as % of GDP) in 1971?
Keep it short and to the point. 19. What is the difference between the highest and the lowest Rent(as % of GDP) in 1972?
Provide a succinct answer. 19.63. What is the difference between the highest and the lowest Rent(as % of GDP) in 1973?
Keep it short and to the point. 15.31. 